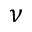<formula> <loc_0><loc_0><loc_500><loc_500>\nu</formula> 